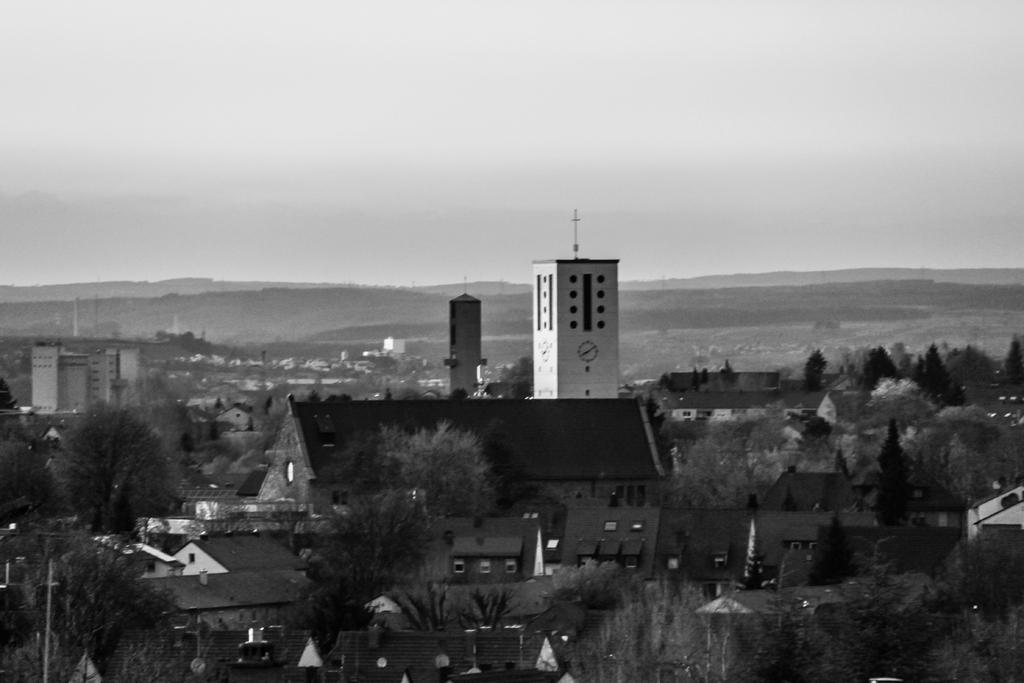Can you describe this image briefly? In this picture I can observe some trees. There are buildings in this picture. In the background there is sky. 